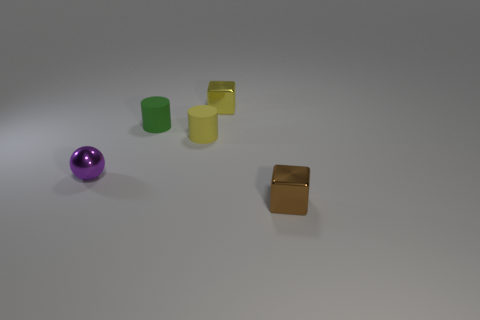The yellow matte thing has what size?
Keep it short and to the point. Small. There is a tiny metallic block in front of the object left of the tiny green cylinder; is there a tiny matte cylinder right of it?
Provide a short and direct response. No. The purple thing that is the same size as the green matte object is what shape?
Provide a succinct answer. Sphere. How many tiny things are yellow things or purple objects?
Provide a succinct answer. 3. The other tiny cylinder that is the same material as the green cylinder is what color?
Ensure brevity in your answer.  Yellow. There is a tiny metallic thing on the left side of the yellow cube; is its shape the same as the tiny metal thing that is on the right side of the yellow cube?
Offer a terse response. No. What number of rubber things are either tiny cubes or brown blocks?
Make the answer very short. 0. Are there any other things that have the same shape as the brown shiny object?
Your answer should be very brief. Yes. There is a tiny block that is behind the green rubber cylinder; what is it made of?
Ensure brevity in your answer.  Metal. Is the material of the small cube to the left of the brown metal thing the same as the tiny ball?
Your answer should be compact. Yes. 